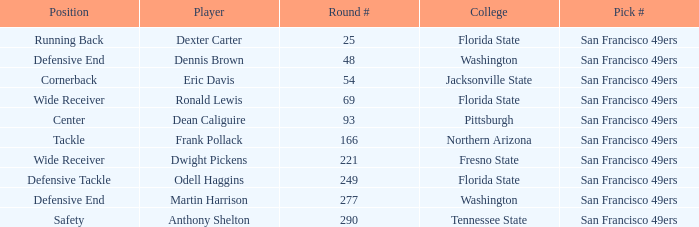What is the College with a Player that is dean caliguire? Pittsburgh. 